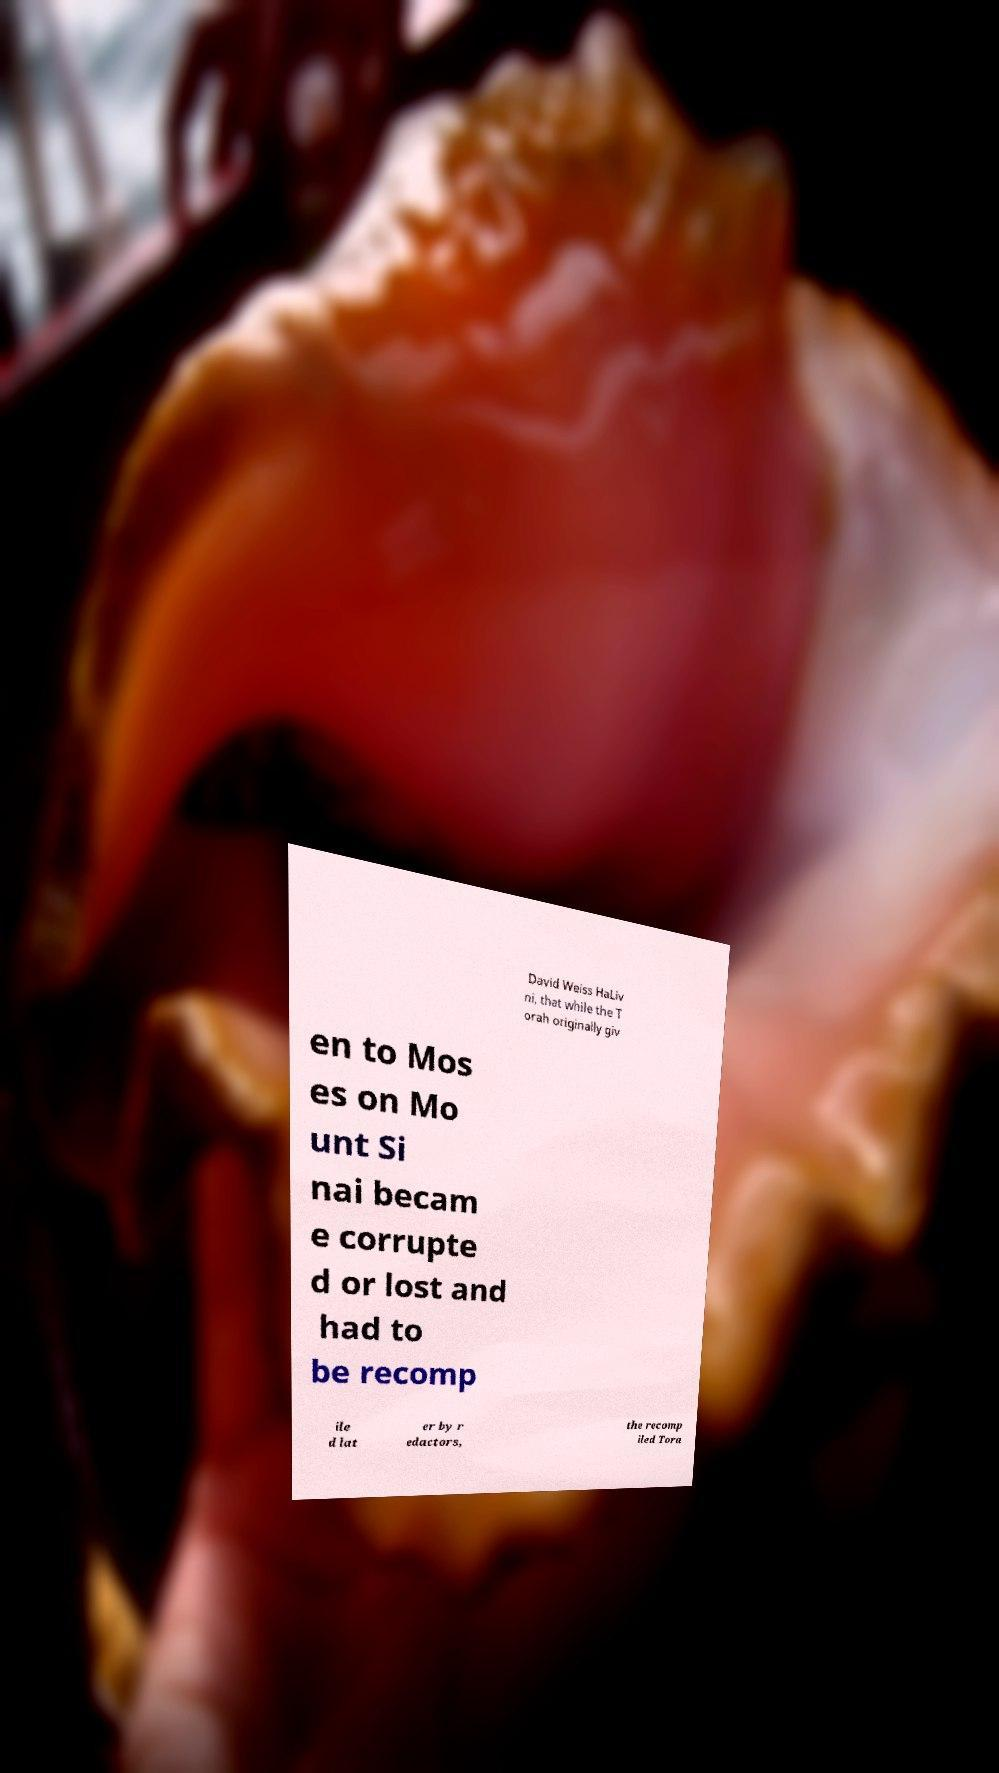Can you accurately transcribe the text from the provided image for me? David Weiss HaLiv ni, that while the T orah originally giv en to Mos es on Mo unt Si nai becam e corrupte d or lost and had to be recomp ile d lat er by r edactors, the recomp iled Tora 